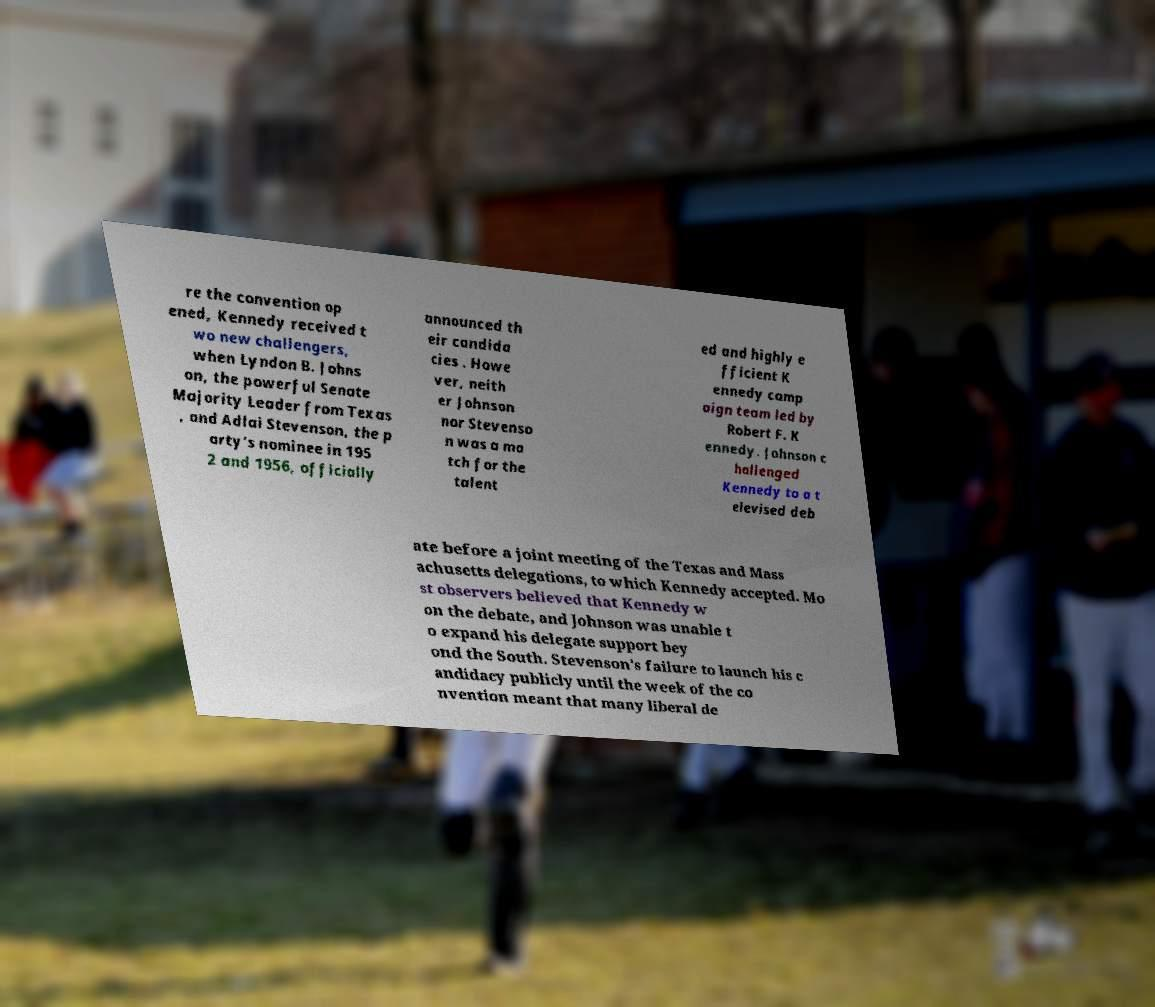Please identify and transcribe the text found in this image. re the convention op ened, Kennedy received t wo new challengers, when Lyndon B. Johns on, the powerful Senate Majority Leader from Texas , and Adlai Stevenson, the p arty's nominee in 195 2 and 1956, officially announced th eir candida cies . Howe ver, neith er Johnson nor Stevenso n was a ma tch for the talent ed and highly e fficient K ennedy camp aign team led by Robert F. K ennedy. Johnson c hallenged Kennedy to a t elevised deb ate before a joint meeting of the Texas and Mass achusetts delegations, to which Kennedy accepted. Mo st observers believed that Kennedy w on the debate, and Johnson was unable t o expand his delegate support bey ond the South. Stevenson's failure to launch his c andidacy publicly until the week of the co nvention meant that many liberal de 